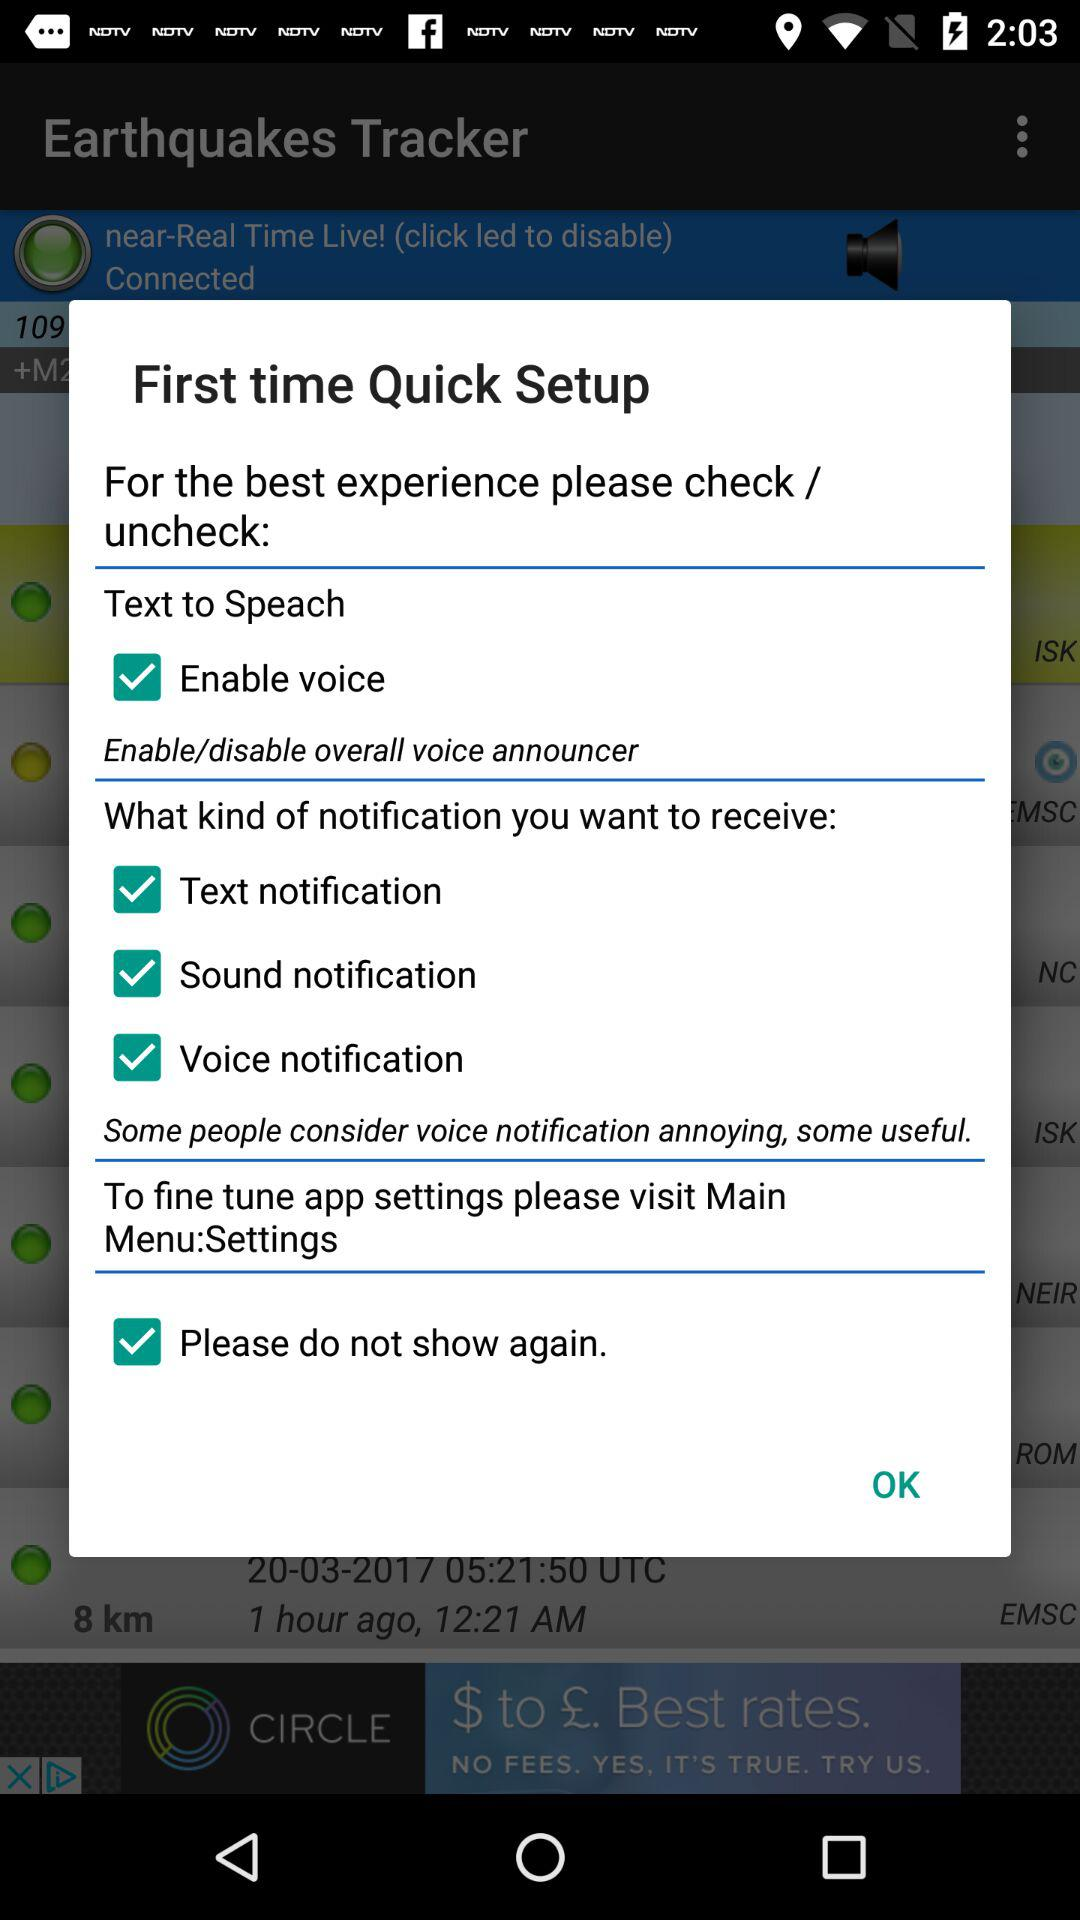How many notification types can I choose from?
Answer the question using a single word or phrase. 3 